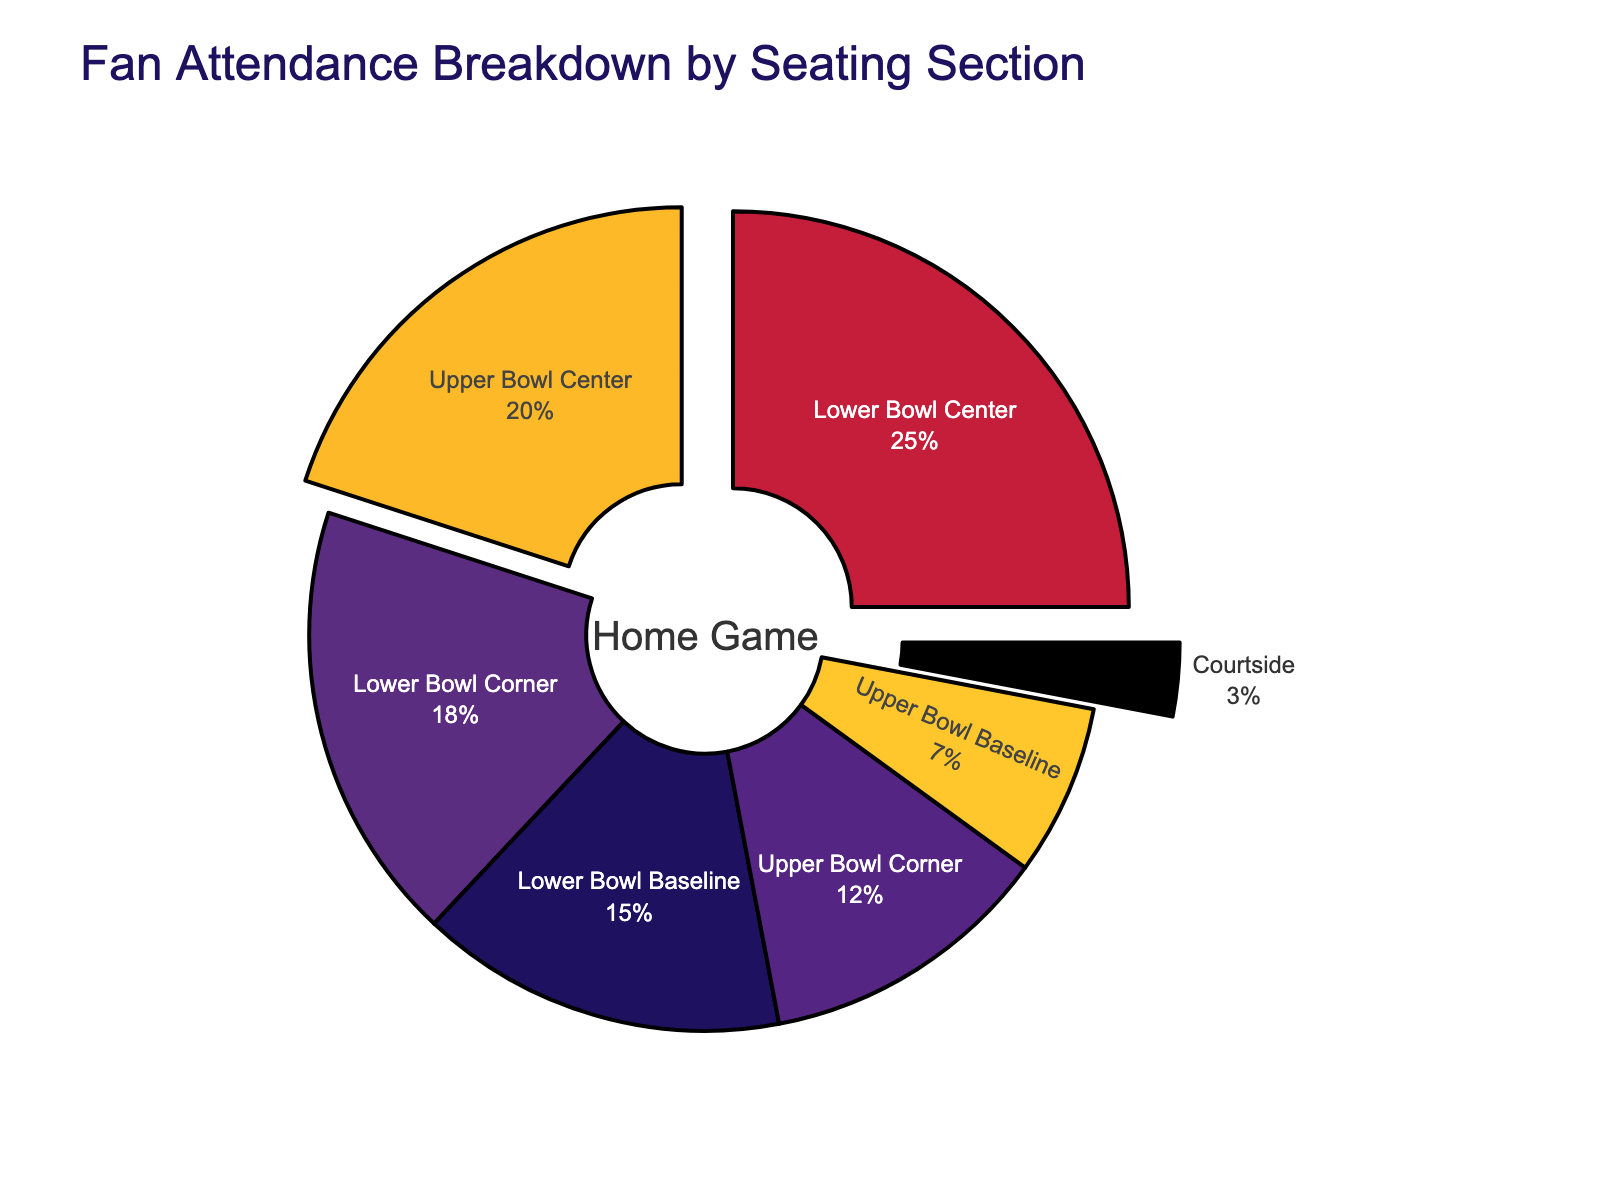Which section has the highest fan attendance? The section with the highest percentage values in the pie chart indicates the highest fan attendance. "Lower Bowl Center" holds 25%, the largest percentage.
Answer: Lower Bowl Center Which section has the lowest fan attendance? The section with the smallest percentage values in the pie chart indicates the lowest fan attendance. "Courtside" holds 3%, the smallest percentage.
Answer: Courtside What is the combined percentage of attendance in the Lower Bowl sections? The total percentage of all Lower Bowl sections is the sum of their individual percentages: Lower Bowl Center (25%), Lower Bowl Corner (18%), Lower Bowl Baseline (15%). Adding them gives 25% + 18% + 15% = 58%.
Answer: 58% Are there more fans in the Upper Bowl Center or in all Upper Bowl Corners combined? Compare the percentage values: Upper Bowl Center has 20%, while Upper Bowl Corner has 12%. 20% (Upper Bowl Center) > 12% (Upper Bowl Corners).
Answer: Upper Bowl Center What proportion of the attendance do all baseline seats make up? Add the percentages for the Lower Bowl Baseline (15%) and Upper Bowl Baseline (7%) sections: 15% + 7% = 22%.
Answer: 22% Which sections are pulled out in the pie chart? The sections are visually highlighted by being pulled out slightly from the main pie chart. The labels for these sections are "Lower Bowl Center," "Upper Bowl Center," and "Courtside."
Answer: Lower Bowl Center, Upper Bowl Center, Courtside What is the difference in fan attendance percentage between Upper Bowl Center and Lower Bowl Corner? Subtract the percentage of Lower Bowl Corner (18%) from Upper Bowl Center (20%): 20% - 18% = 2%.
Answer: 2% How does the attendance of Upper Bowl Center compare to Upper Bowl Baseline? Upper Bowl Center has a percentage of 20%, while Upper Bowl Baseline has 7%. So, Upper Bowl Center > Upper Bowl Baseline.
Answer: Upper Bowl Center What's the total percentage of fan attendance in the upper sections? Sum the percentages of Upper Bowl Center (20%), Upper Bowl Corner (12%), and Upper Bowl Baseline (7%): 20% + 12% + 7% = 39%.
Answer: 39% What is the ratio of Lower Bowl Center attendance to Courtside attendance? Divide the percentage of Lower Bowl Center (25%) by Courtside (3%): 25 / 3 ≈ 8.33.
Answer: 8.33 